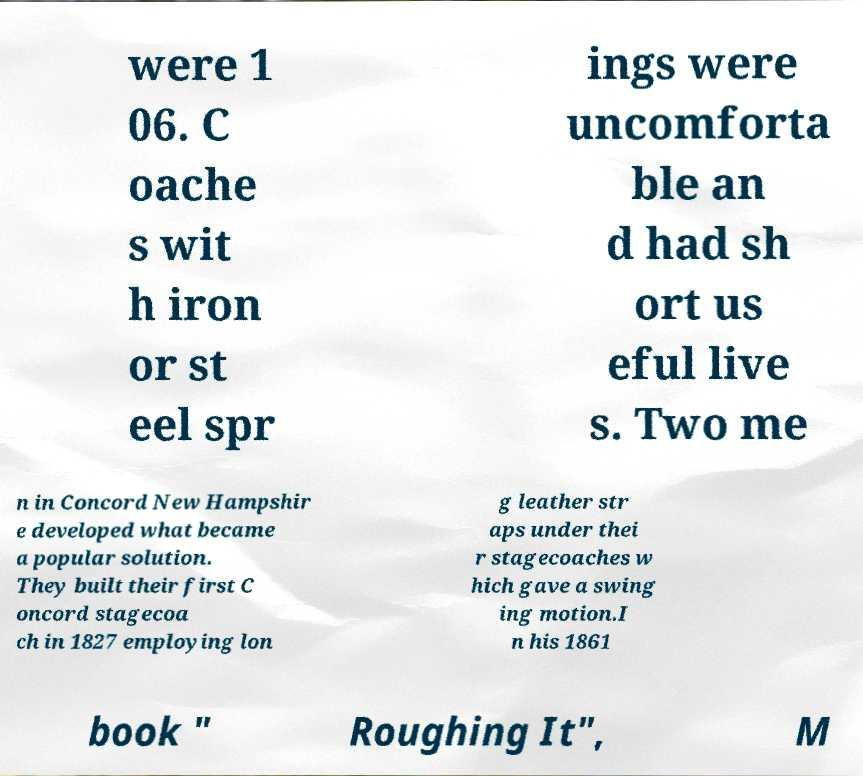There's text embedded in this image that I need extracted. Can you transcribe it verbatim? were 1 06. C oache s wit h iron or st eel spr ings were uncomforta ble an d had sh ort us eful live s. Two me n in Concord New Hampshir e developed what became a popular solution. They built their first C oncord stagecoa ch in 1827 employing lon g leather str aps under thei r stagecoaches w hich gave a swing ing motion.I n his 1861 book " Roughing It", M 